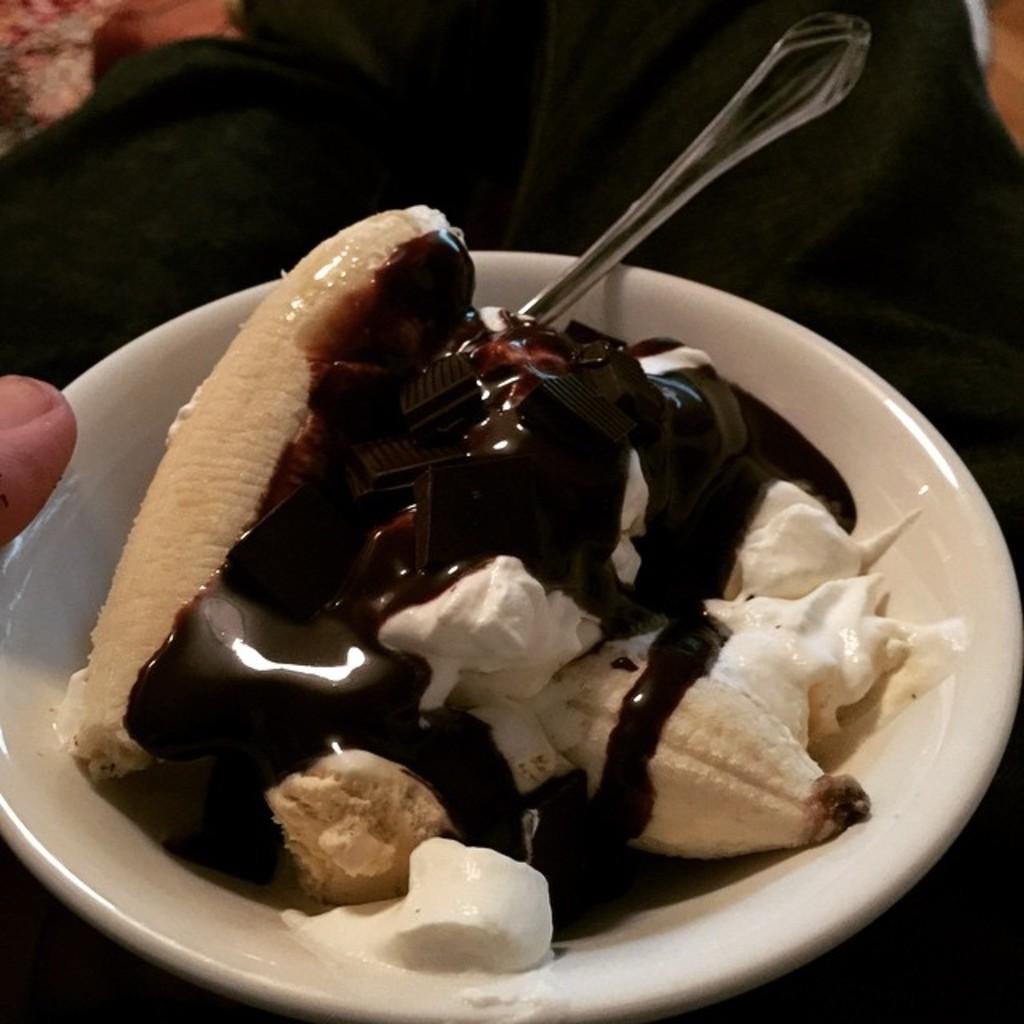What is present in the image that can be used for eating? There is a spoon in the image that can be used for eating. What is contained within the bowl in the image? There is food in the image, which is contained within the bowl. What can be observed about the lighting in the image? The background of the image is dark, indicating that the lighting may be dim or low. Can you hear the structure laughing in the image? There is no structure present in the image, and therefore it cannot be heard laughing. 